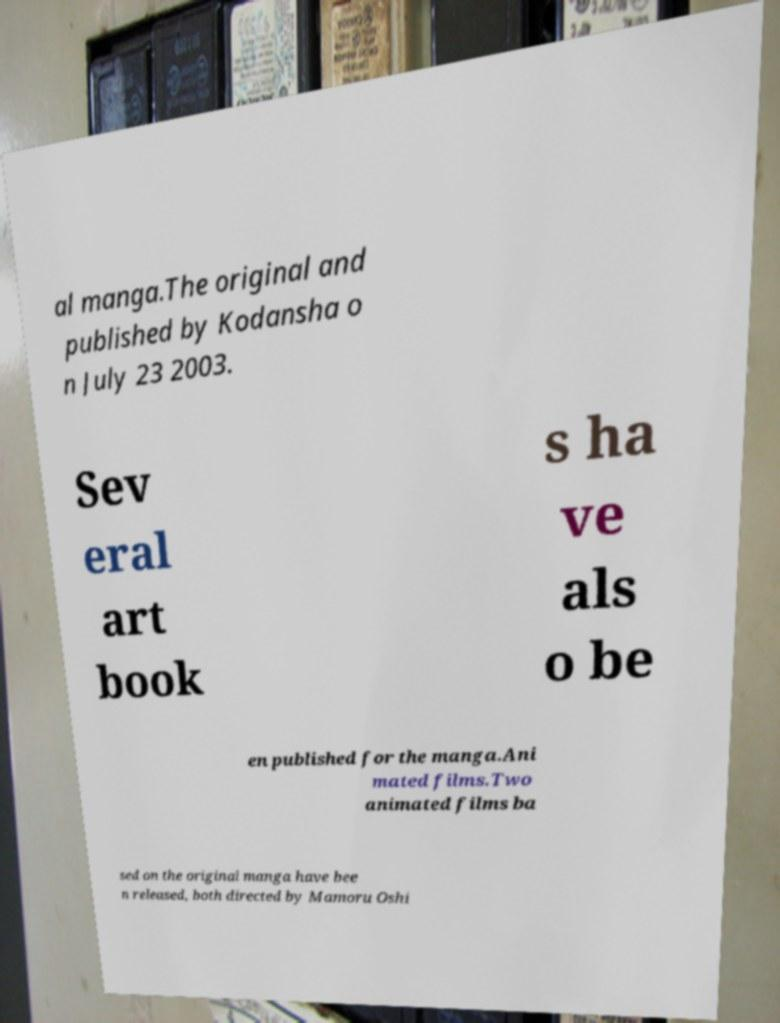Please read and relay the text visible in this image. What does it say? al manga.The original and published by Kodansha o n July 23 2003. Sev eral art book s ha ve als o be en published for the manga.Ani mated films.Two animated films ba sed on the original manga have bee n released, both directed by Mamoru Oshi 